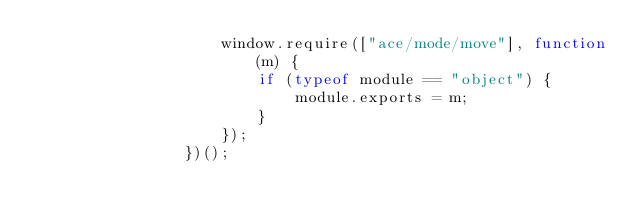<code> <loc_0><loc_0><loc_500><loc_500><_JavaScript_>                    window.require(["ace/mode/move"], function(m) {
                        if (typeof module == "object") {
                            module.exports = m;
                        }
                    });
                })();
            </code> 